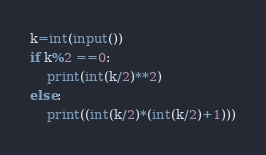Convert code to text. <code><loc_0><loc_0><loc_500><loc_500><_Python_>k=int(input())
if k%2 ==0:
    print(int(k/2)**2)
else:
    print((int(k/2)*(int(k/2)+1)))</code> 